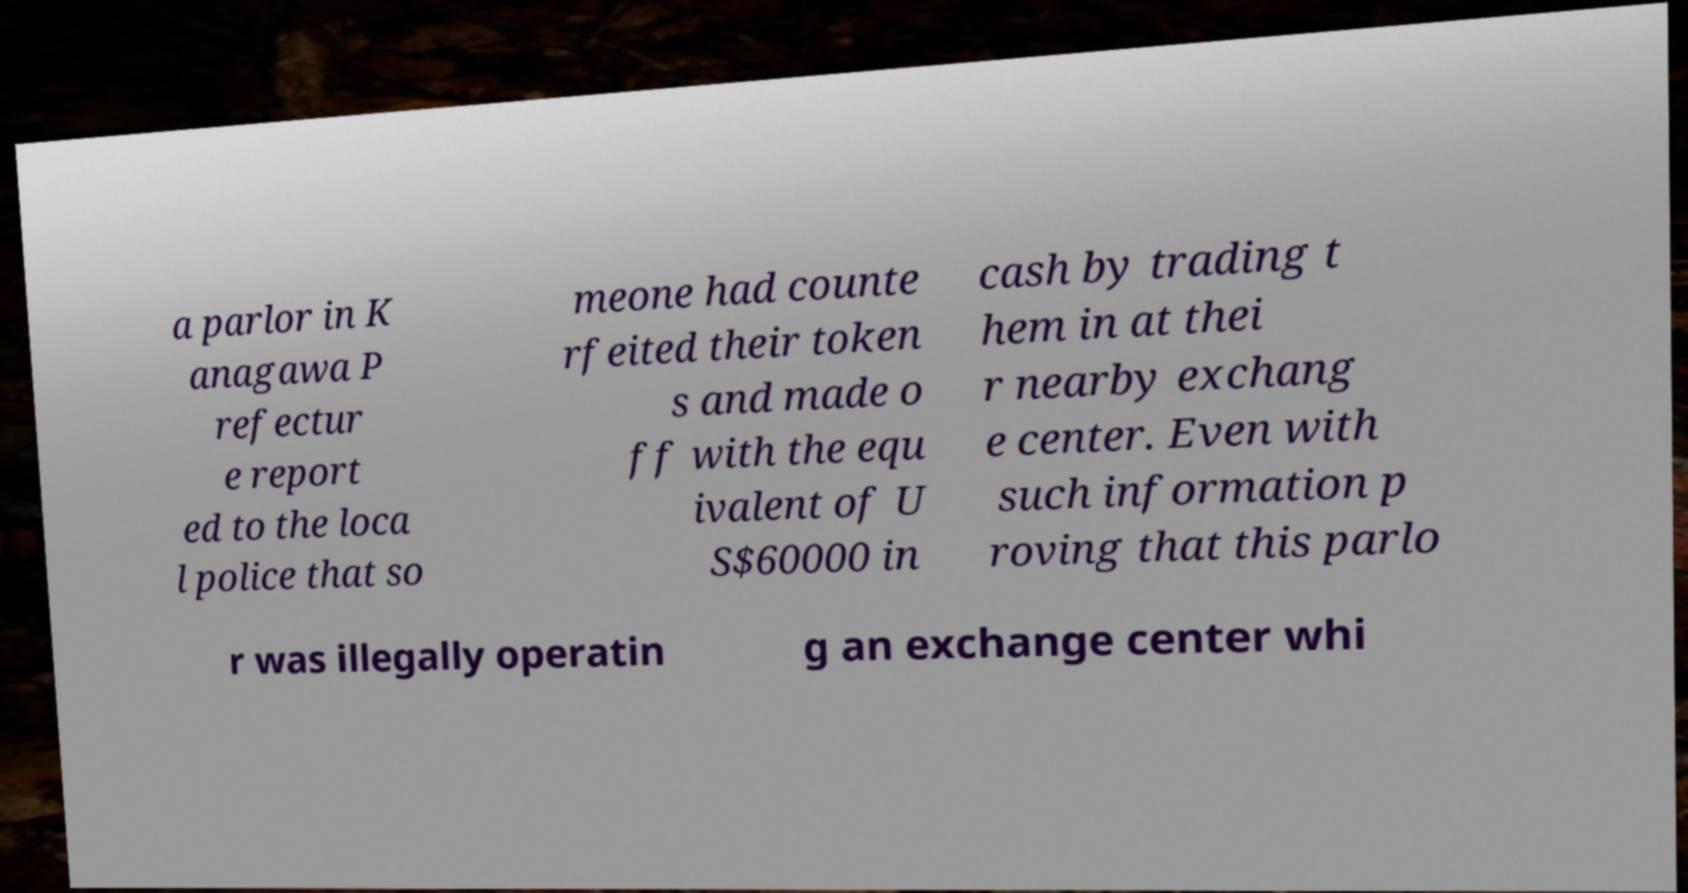Could you assist in decoding the text presented in this image and type it out clearly? a parlor in K anagawa P refectur e report ed to the loca l police that so meone had counte rfeited their token s and made o ff with the equ ivalent of U S$60000 in cash by trading t hem in at thei r nearby exchang e center. Even with such information p roving that this parlo r was illegally operatin g an exchange center whi 